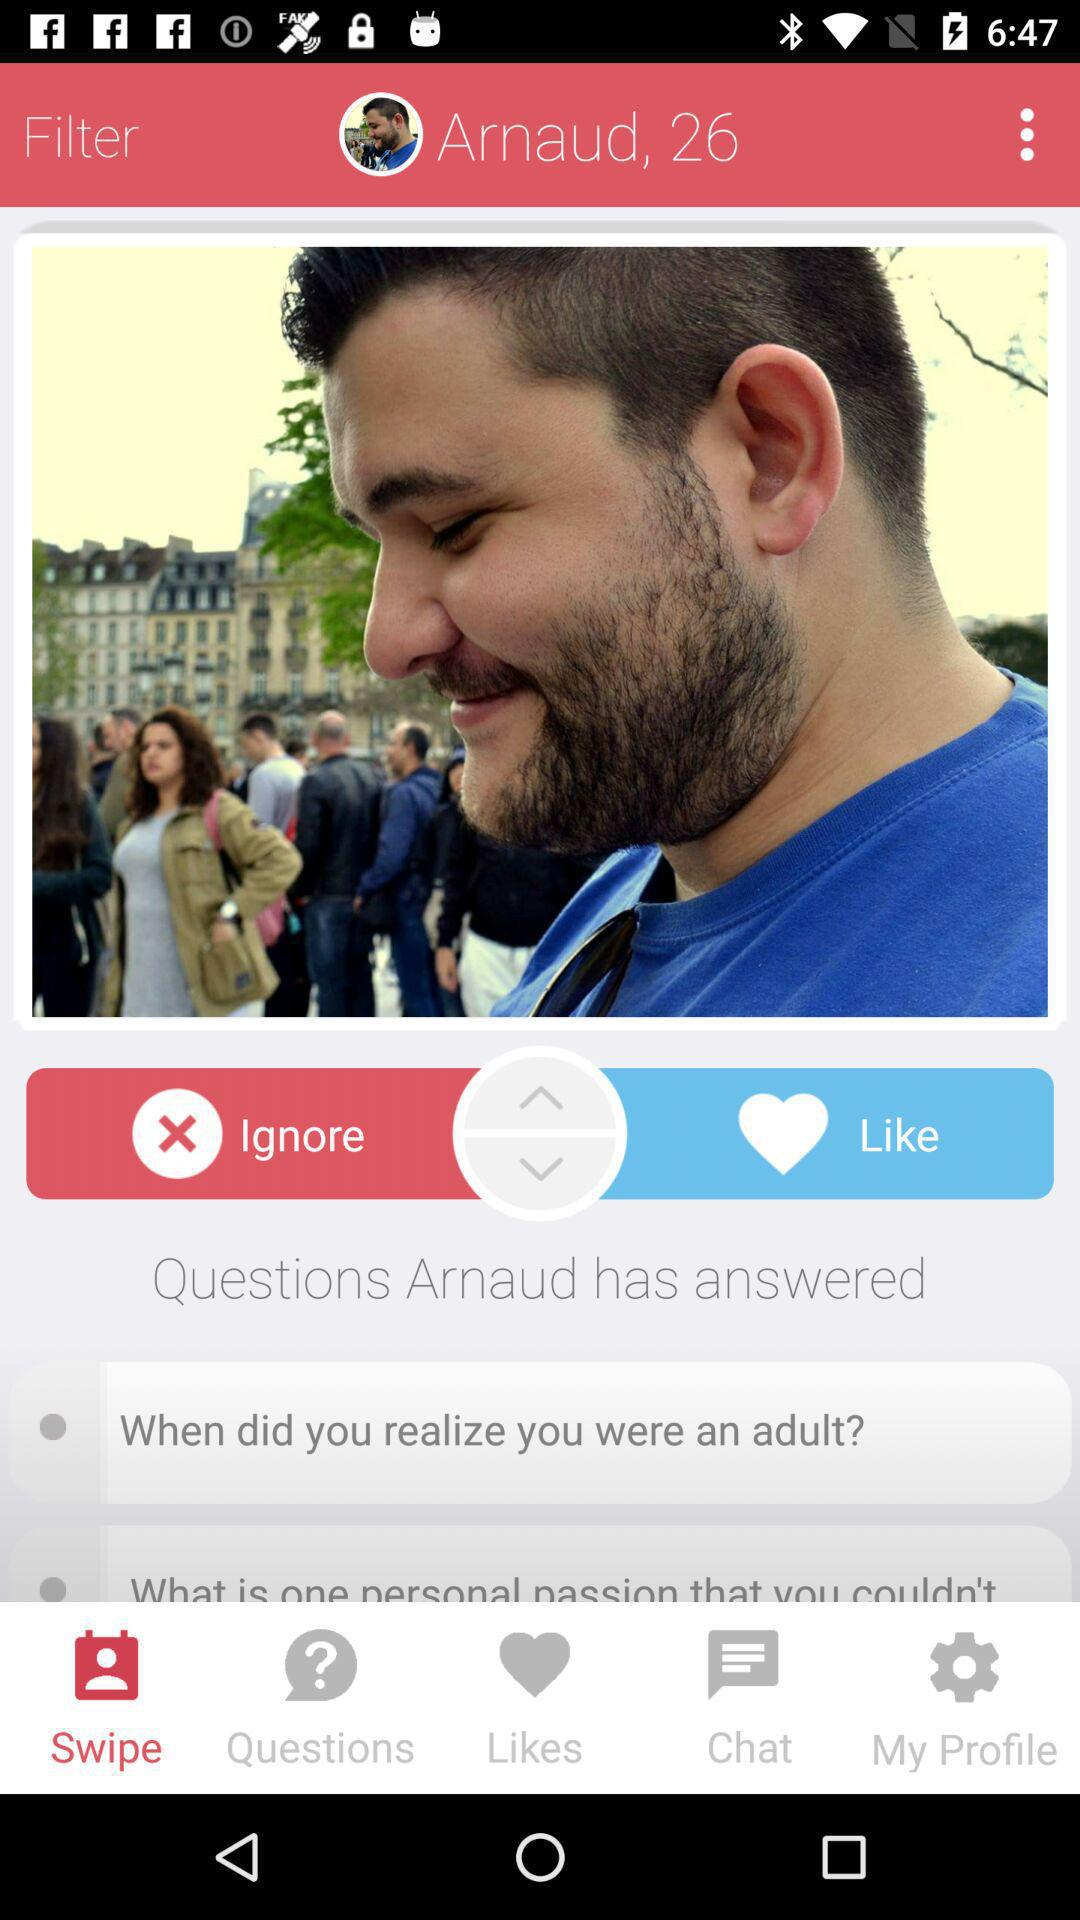Which tab is selected? The selected tab is "Swipe". 